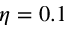<formula> <loc_0><loc_0><loc_500><loc_500>\eta = 0 . 1</formula> 